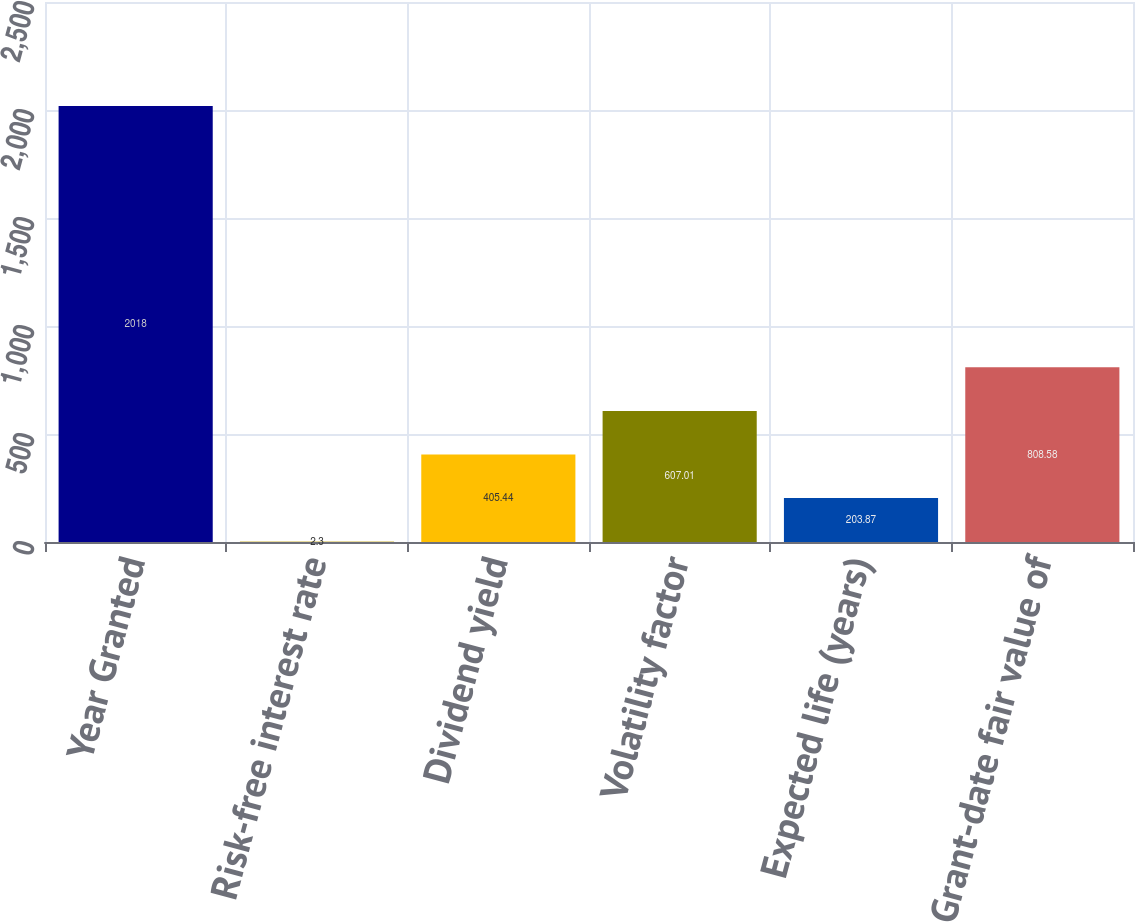Convert chart to OTSL. <chart><loc_0><loc_0><loc_500><loc_500><bar_chart><fcel>Year Granted<fcel>Risk-free interest rate<fcel>Dividend yield<fcel>Volatility factor<fcel>Expected life (years)<fcel>Grant-date fair value of<nl><fcel>2018<fcel>2.3<fcel>405.44<fcel>607.01<fcel>203.87<fcel>808.58<nl></chart> 